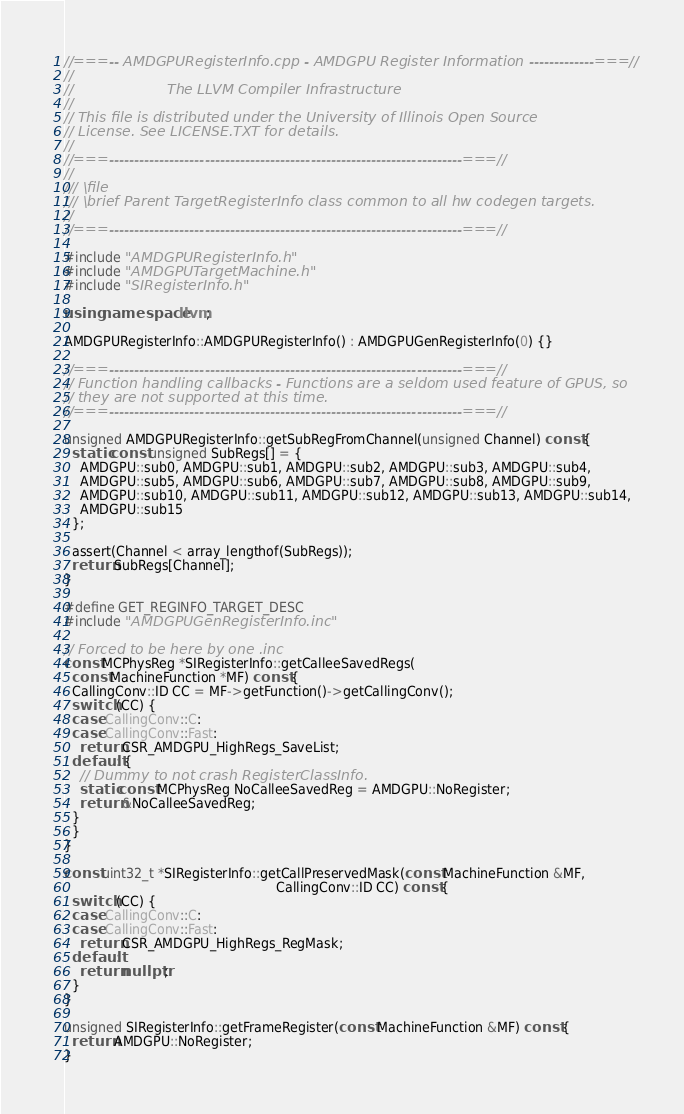Convert code to text. <code><loc_0><loc_0><loc_500><loc_500><_C++_>//===-- AMDGPURegisterInfo.cpp - AMDGPU Register Information -------------===//
//
//                     The LLVM Compiler Infrastructure
//
// This file is distributed under the University of Illinois Open Source
// License. See LICENSE.TXT for details.
//
//===----------------------------------------------------------------------===//
//
/// \file
/// \brief Parent TargetRegisterInfo class common to all hw codegen targets.
//
//===----------------------------------------------------------------------===//

#include "AMDGPURegisterInfo.h"
#include "AMDGPUTargetMachine.h"
#include "SIRegisterInfo.h"

using namespace llvm;

AMDGPURegisterInfo::AMDGPURegisterInfo() : AMDGPUGenRegisterInfo(0) {}

//===----------------------------------------------------------------------===//
// Function handling callbacks - Functions are a seldom used feature of GPUS, so
// they are not supported at this time.
//===----------------------------------------------------------------------===//

unsigned AMDGPURegisterInfo::getSubRegFromChannel(unsigned Channel) const {
  static const unsigned SubRegs[] = {
    AMDGPU::sub0, AMDGPU::sub1, AMDGPU::sub2, AMDGPU::sub3, AMDGPU::sub4,
    AMDGPU::sub5, AMDGPU::sub6, AMDGPU::sub7, AMDGPU::sub8, AMDGPU::sub9,
    AMDGPU::sub10, AMDGPU::sub11, AMDGPU::sub12, AMDGPU::sub13, AMDGPU::sub14,
    AMDGPU::sub15
  };

  assert(Channel < array_lengthof(SubRegs));
  return SubRegs[Channel];
}

#define GET_REGINFO_TARGET_DESC
#include "AMDGPUGenRegisterInfo.inc"

// Forced to be here by one .inc
const MCPhysReg *SIRegisterInfo::getCalleeSavedRegs(
  const MachineFunction *MF) const {
  CallingConv::ID CC = MF->getFunction()->getCallingConv();
  switch (CC) {
  case CallingConv::C:
  case CallingConv::Fast:
    return CSR_AMDGPU_HighRegs_SaveList;
  default: {
    // Dummy to not crash RegisterClassInfo.
    static const MCPhysReg NoCalleeSavedReg = AMDGPU::NoRegister;
    return &NoCalleeSavedReg;
  }
  }
}

const uint32_t *SIRegisterInfo::getCallPreservedMask(const MachineFunction &MF,
                                                     CallingConv::ID CC) const {
  switch (CC) {
  case CallingConv::C:
  case CallingConv::Fast:
    return CSR_AMDGPU_HighRegs_RegMask;
  default:
    return nullptr;
  }
}

unsigned SIRegisterInfo::getFrameRegister(const MachineFunction &MF) const {
  return AMDGPU::NoRegister;
}
</code> 